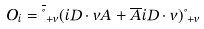Convert formula to latex. <formula><loc_0><loc_0><loc_500><loc_500>O _ { i } = \overline { \Psi } _ { + v } ( i D \cdot v A + \overline { A } i D \cdot v ) \Psi _ { + v }</formula> 